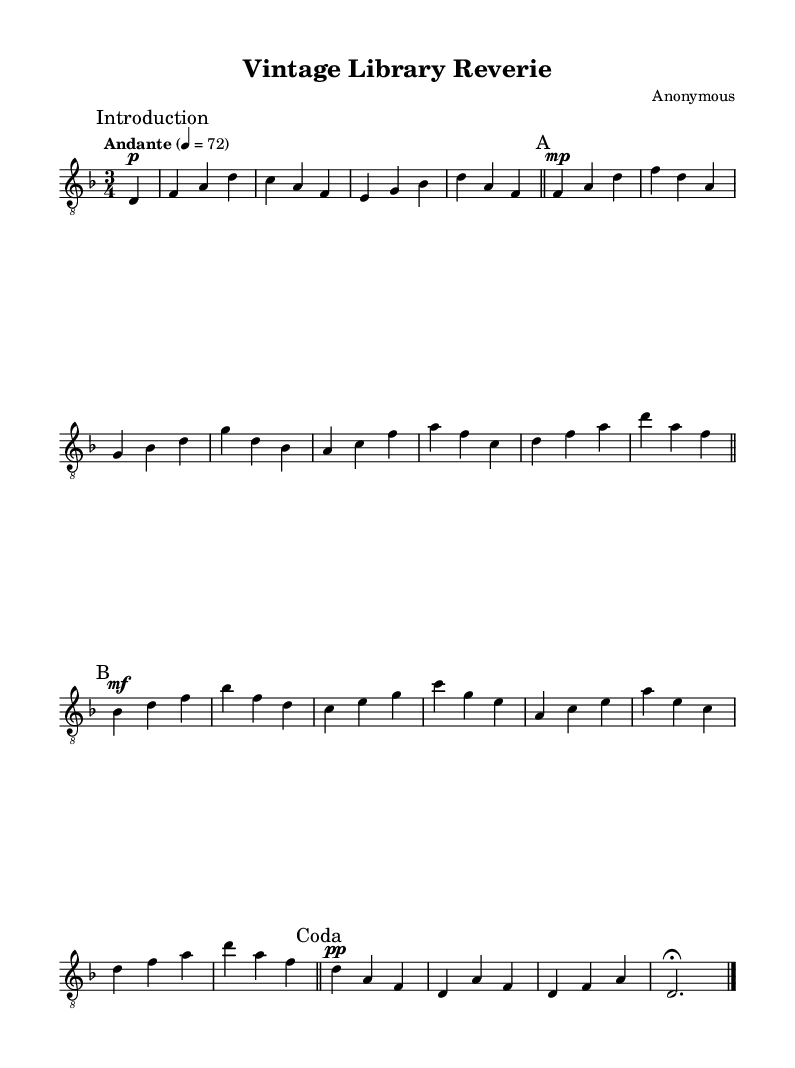What is the key signature of this music? The key signature is indicated at the beginning of the sheet music, showing one flat. Thus, the key signature corresponds to D minor, which has one flat (B flat).
Answer: D minor What is the time signature of this music? The time signature is shown right after the key signature, indicated by two numbers that represent the number of beats per measure and the note that receives one beat. In this case, it is three beats per measure.
Answer: 3/4 What tempo marking is used in this composition? The tempo marking is specified in the score, indicating the speed at which the piece should be played. The mark "Andante" suggests a moderately slow pace.
Answer: Andante How many measures are in Section A? Section A is marked with a section label in the score. Counting the measures in this section shows there are six measures in total.
Answer: 6 What dynamic marking is used in the introduction? The dynamic marking is found next to the introduction section, which indicates how loudly or softly the music should be played. In this case, it shows "p", indicating a soft volume.
Answer: p Which instrument is specified for this score? The instrument type is noted in the score, specifically indicating the intended instrument for performance. In this instance, it specifies "acoustic guitar (nylon)", which describes the type of guitar used.
Answer: acoustic guitar (nylon) 